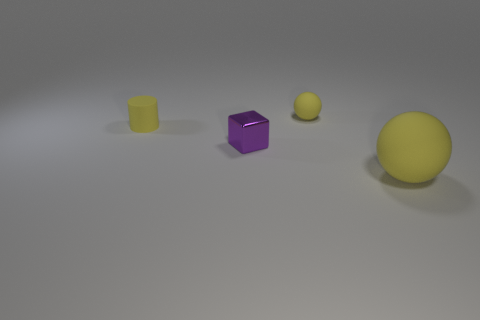How many yellow things have the same shape as the purple metal object?
Give a very brief answer. 0. Are there more tiny yellow rubber objects right of the shiny object than big red matte objects?
Offer a terse response. Yes. There is a matte thing that is on the right side of the purple block and behind the tiny shiny block; what is its shape?
Provide a succinct answer. Sphere. What number of yellow things are on the left side of the tiny purple cube?
Your response must be concise. 1. Is the number of metallic cubes behind the metal cube the same as the number of rubber objects that are in front of the tiny cylinder?
Make the answer very short. No. There is a small object that is behind the rubber cylinder; is it the same shape as the big yellow thing?
Keep it short and to the point. Yes. Is there any other thing that is the same material as the purple block?
Ensure brevity in your answer.  No. There is a purple object; is it the same size as the rubber object that is in front of the purple cube?
Provide a short and direct response. No. What number of other objects are there of the same color as the big matte ball?
Your response must be concise. 2. Are there any objects to the left of the small yellow ball?
Offer a terse response. Yes. 